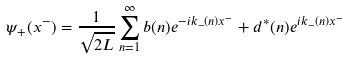<formula> <loc_0><loc_0><loc_500><loc_500>\psi _ { + } ( x ^ { - } ) = \frac { 1 } { \sqrt { 2 L } } \sum _ { n = 1 } ^ { \infty } b ( n ) e ^ { - i k _ { - } ( n ) x ^ { - } } + d ^ { * } ( n ) e ^ { i k _ { - } ( n ) x ^ { - } }</formula> 